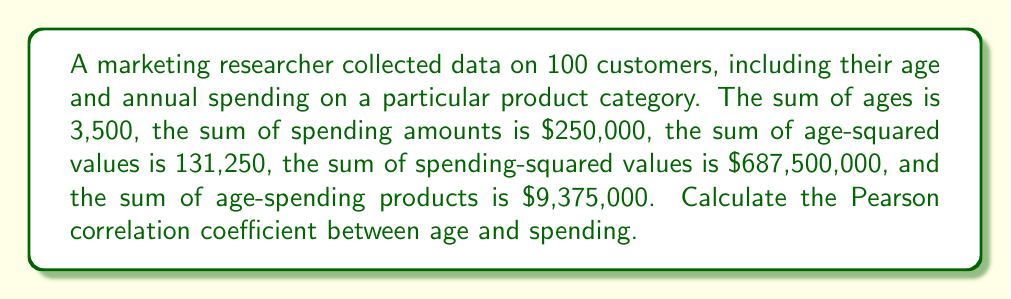Can you solve this math problem? To calculate the Pearson correlation coefficient, we'll use the formula:

$$ r = \frac{n\sum xy - \sum x \sum y}{\sqrt{[n\sum x^2 - (\sum x)^2][n\sum y^2 - (\sum y)^2]}} $$

Where:
$n$ = number of observations
$x$ = age
$y$ = spending

Given:
$n = 100$
$\sum x = 3,500$
$\sum y = 250,000$
$\sum x^2 = 131,250$
$\sum y^2 = 687,500,000$
$\sum xy = 9,375,000$

Step 1: Calculate the numerator
$n\sum xy - \sum x \sum y = (100 \times 9,375,000) - (3,500 \times 250,000) = 62,500,000$

Step 2: Calculate the first part of the denominator
$n\sum x^2 - (\sum x)^2 = (100 \times 131,250) - (3,500)^2 = 625,000$

Step 3: Calculate the second part of the denominator
$n\sum y^2 - (\sum y)^2 = (100 \times 687,500,000) - (250,000)^2 = 6,250,000,000$

Step 4: Multiply the two parts of the denominator and take the square root
$\sqrt{625,000 \times 6,250,000,000} = 62,500,000$

Step 5: Divide the numerator by the denominator
$r = \frac{62,500,000}{62,500,000} = 1$
Answer: $r = 1$ 